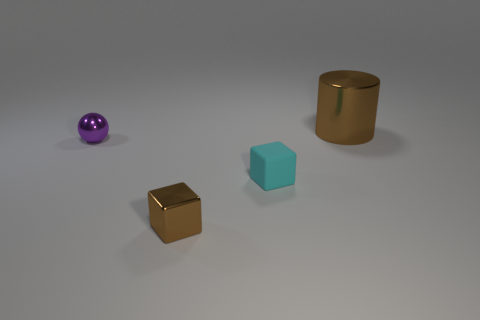Are there any red cubes made of the same material as the tiny cyan block?
Keep it short and to the point. No. The metal sphere is what size?
Ensure brevity in your answer.  Small. How big is the metallic object in front of the small block that is on the right side of the tiny brown object?
Keep it short and to the point. Small. There is another small object that is the same shape as the tiny brown thing; what material is it?
Make the answer very short. Rubber. How many brown cylinders are there?
Give a very brief answer. 1. There is a tiny metal thing behind the small block to the right of the small brown metallic block in front of the tiny sphere; what color is it?
Offer a terse response. Purple. Are there fewer green metal cylinders than tiny purple objects?
Your answer should be compact. Yes. There is another tiny object that is the same shape as the tiny cyan thing; what color is it?
Give a very brief answer. Brown. What color is the large cylinder that is the same material as the tiny brown object?
Offer a terse response. Brown. What number of cyan matte cylinders have the same size as the cyan thing?
Keep it short and to the point. 0. 